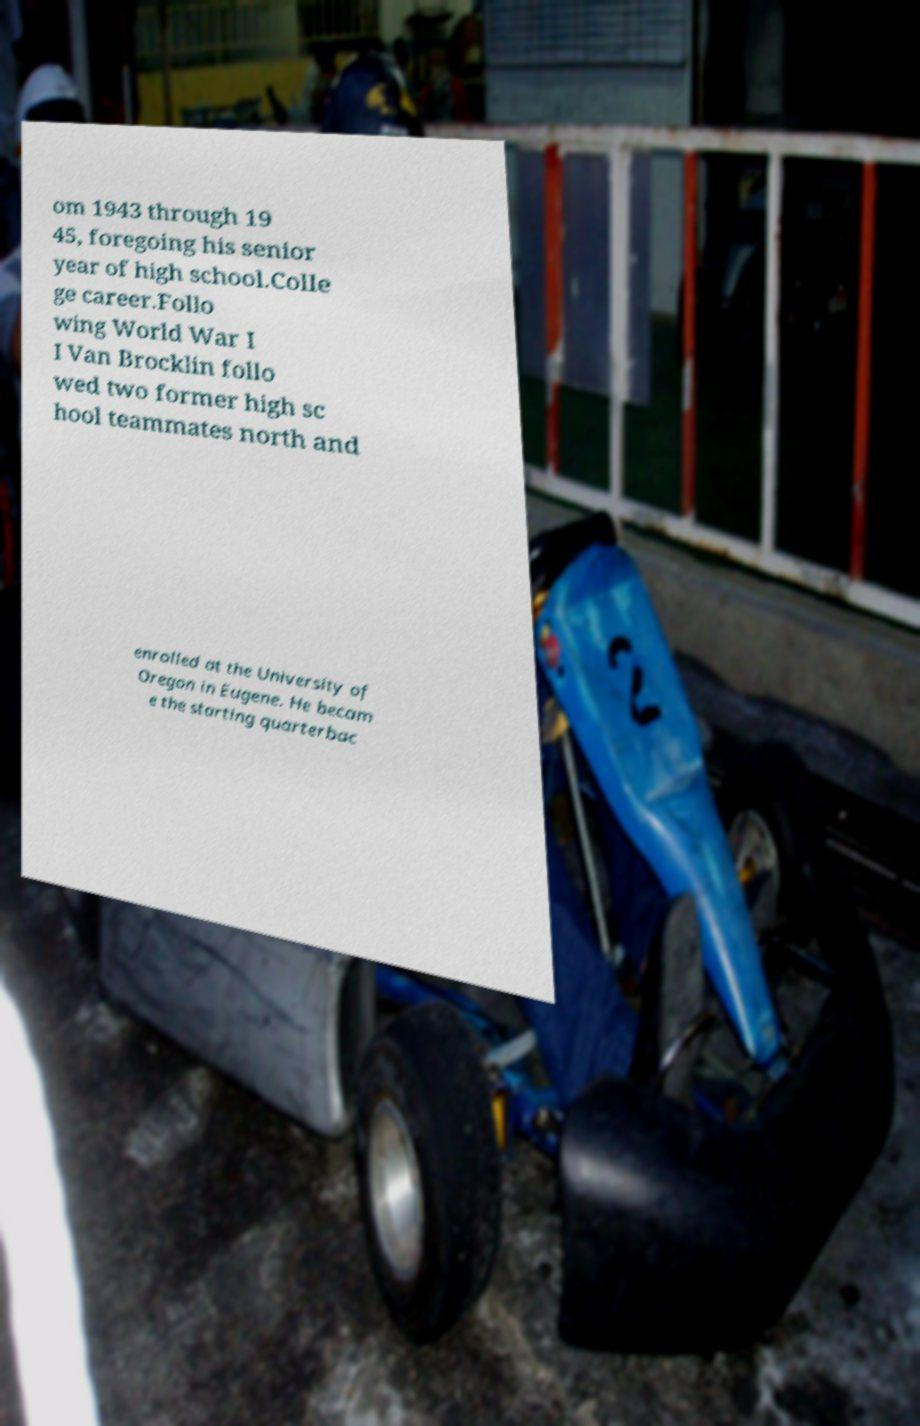I need the written content from this picture converted into text. Can you do that? om 1943 through 19 45, foregoing his senior year of high school.Colle ge career.Follo wing World War I I Van Brocklin follo wed two former high sc hool teammates north and enrolled at the University of Oregon in Eugene. He becam e the starting quarterbac 